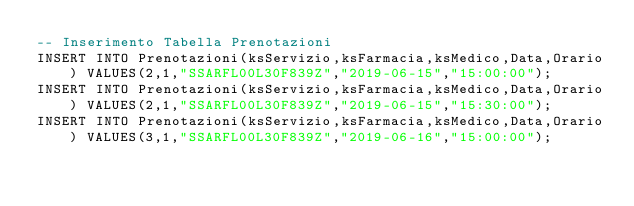<code> <loc_0><loc_0><loc_500><loc_500><_SQL_>-- Inserimento Tabella Prenotazioni
INSERT INTO Prenotazioni(ksServizio,ksFarmacia,ksMedico,Data,Orario) VALUES(2,1,"SSARFL00L30F839Z","2019-06-15","15:00:00");
INSERT INTO Prenotazioni(ksServizio,ksFarmacia,ksMedico,Data,Orario) VALUES(2,1,"SSARFL00L30F839Z","2019-06-15","15:30:00");
INSERT INTO Prenotazioni(ksServizio,ksFarmacia,ksMedico,Data,Orario) VALUES(3,1,"SSARFL00L30F839Z","2019-06-16","15:00:00");</code> 